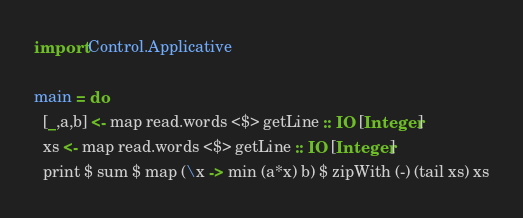<code> <loc_0><loc_0><loc_500><loc_500><_Haskell_>import Control.Applicative

main = do
  [_,a,b] <- map read.words <$> getLine :: IO [Integer]
  xs <- map read.words <$> getLine :: IO [Integer]
  print $ sum $ map (\x -> min (a*x) b) $ zipWith (-) (tail xs) xs
</code> 